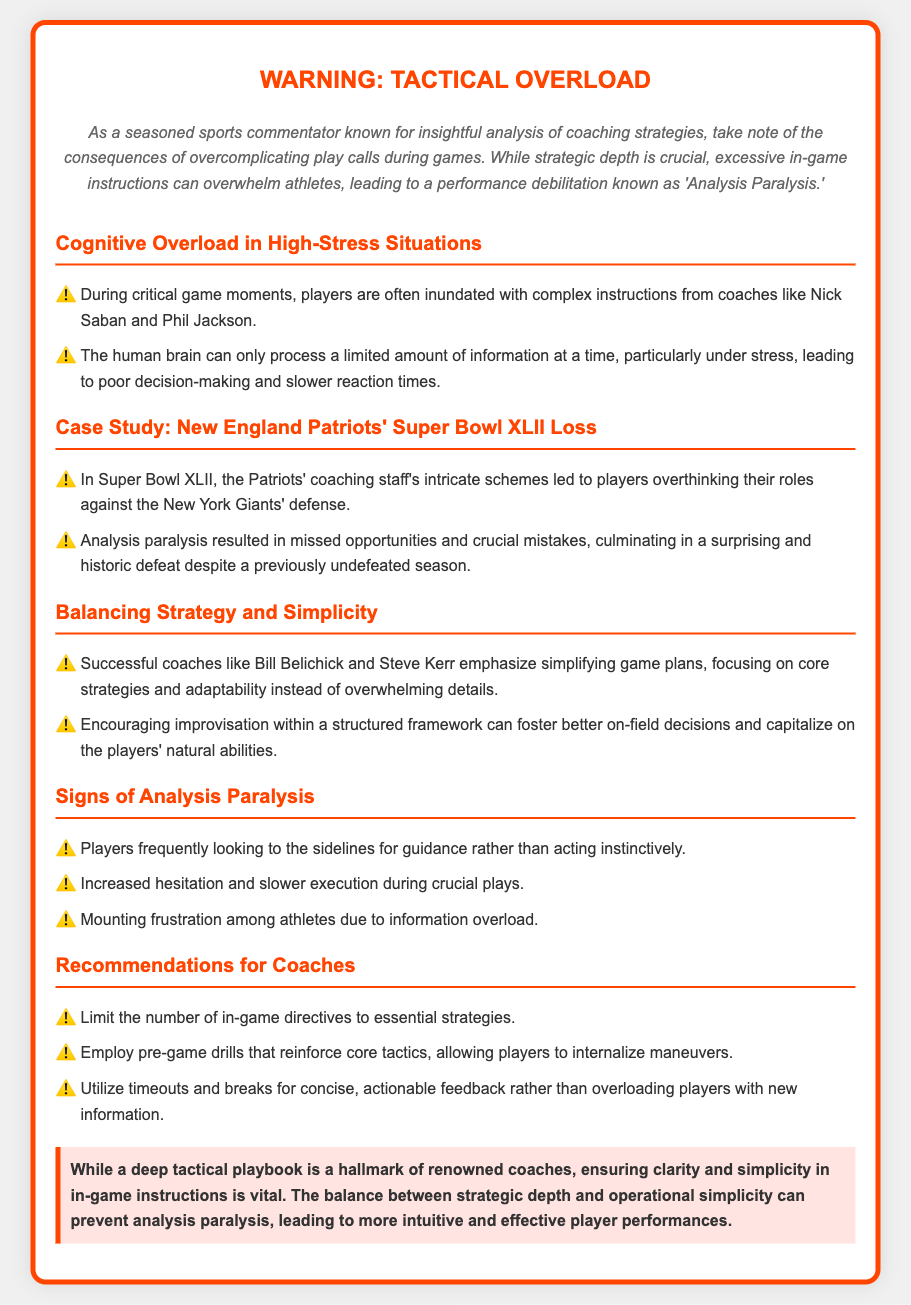What is the title of the warning label? The title of the warning label is prominently displayed at the top of the document, indicating the main topic of concern.
Answer: Warning: Tactical Overload Who is mentioned as a successful coach emphasizing simplicity? The document lists notable coaches who prioritize simple strategies, showcasing a good coaching approach.
Answer: Bill Belichick What negative outcome is associated with excessive in-game strategies? The document highlights a specific negative effect that results from an overwhelming amount of information provided to players.
Answer: Analysis Paralysis What significant event is used as a case study in the document? The case study illustrates a real-world example that highlights the effects of tactical overload during a critical game.
Answer: Super Bowl XLII Loss What should coaches limit during games according to the recommendations? The recommendations section advises on a specific action coaches should take to avoid overwhelming players.
Answer: In-game directives How can players exhibit signs of analysis paralysis? The document describes observable behaviors from players that indicate they are experiencing cognitive overload during a game.
Answer: Looking to the sidelines What color is used for the warning label's border? The visual design of the document specifies a distinct color used in the border to catch attention.
Answer: Orange What is the main focus of the conclusion in the document? The conclusion summarizes the key takeaway about balancing strategic depth and simplicity in coaching methods.
Answer: Clarity and simplicity 